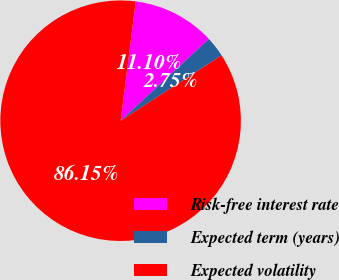Convert chart to OTSL. <chart><loc_0><loc_0><loc_500><loc_500><pie_chart><fcel>Risk-free interest rate<fcel>Expected term (years)<fcel>Expected volatility<nl><fcel>11.1%<fcel>2.75%<fcel>86.16%<nl></chart> 